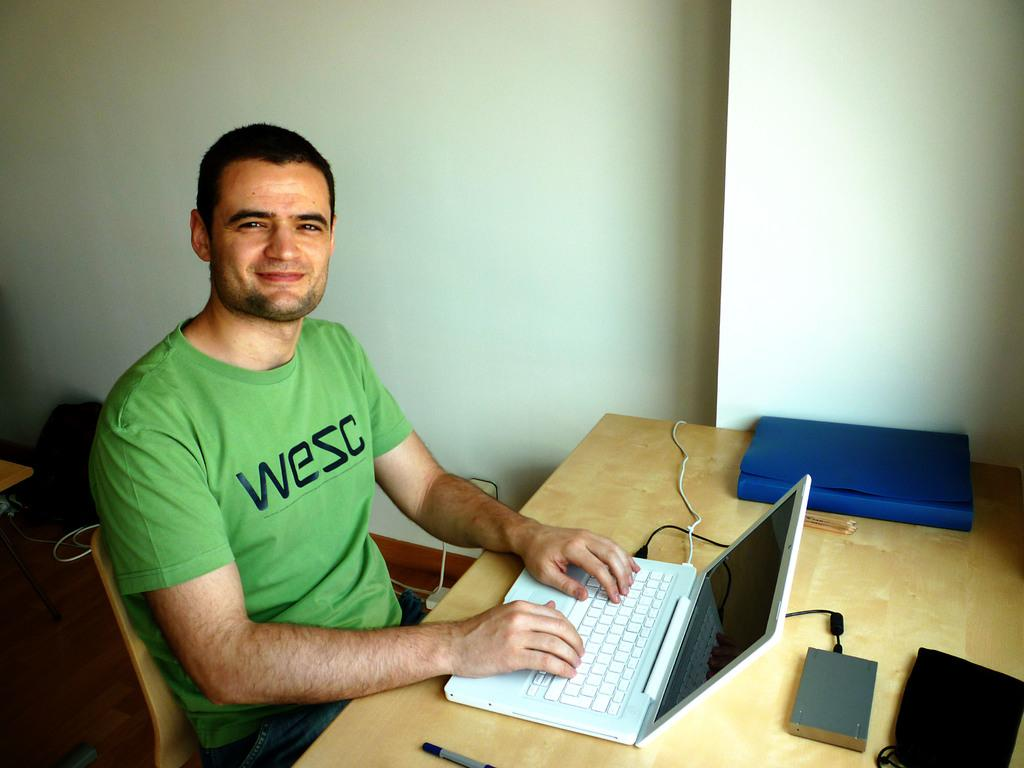Who is present in the image? There is a man in the image. What is the man doing in the image? The man is sitting on a chair. What is the man's facial expression in the image? The man is smiling. What is on the table in the image? There is a laptop and a book on the table. What can be seen in the background of the image? There is a wall in the background of the image. What is visible beneath the man in the image? There is a floor visible in the image. What type of soap is the man using to clean the sand off his quilt in the image? There is no soap, sand, or quilt present in the image. 